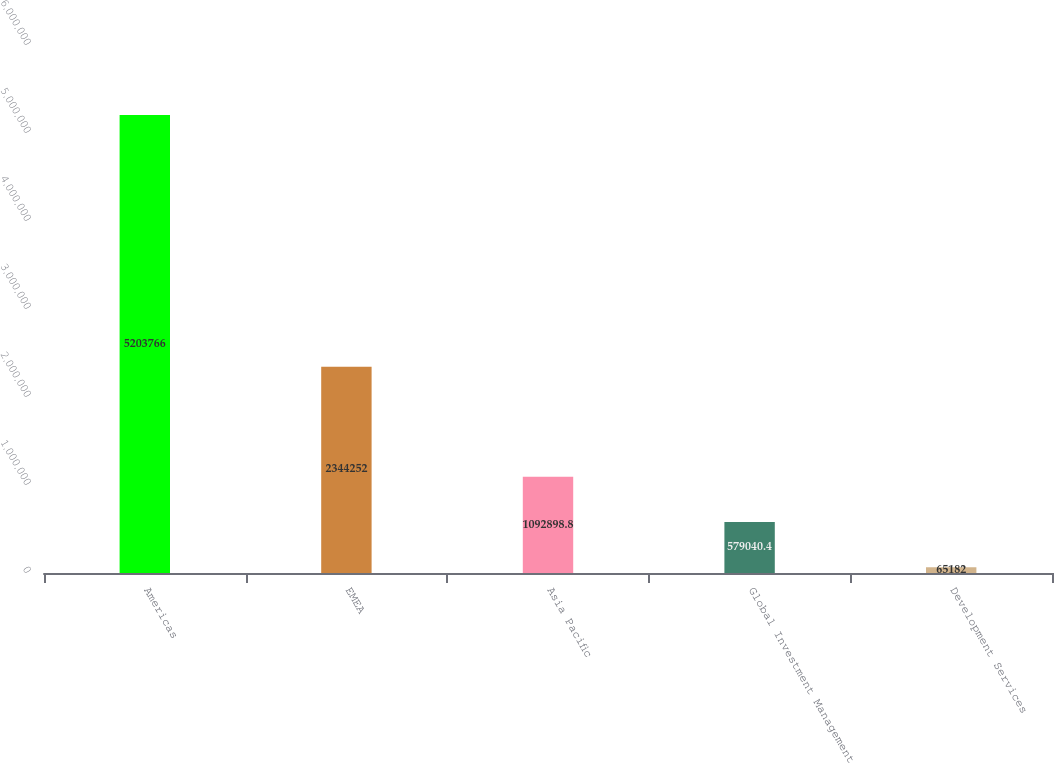Convert chart to OTSL. <chart><loc_0><loc_0><loc_500><loc_500><bar_chart><fcel>Americas<fcel>EMEA<fcel>Asia Pacific<fcel>Global Investment Management<fcel>Development Services<nl><fcel>5.20377e+06<fcel>2.34425e+06<fcel>1.0929e+06<fcel>579040<fcel>65182<nl></chart> 